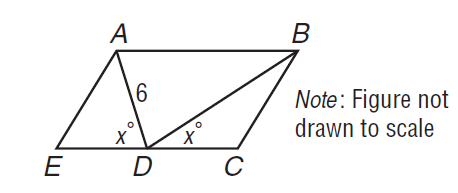Answer the mathemtical geometry problem and directly provide the correct option letter.
Question: In the figure, A B \parallel C E. If D A = 6, what is D B?
Choices: A: 6 B: 7 C: 8 D: 9 A 